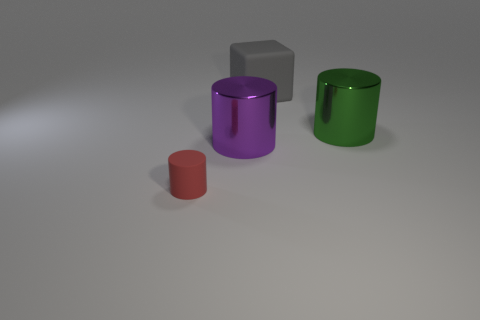There is a cube that is the same material as the red cylinder; what size is it?
Offer a terse response. Large. Is the number of tiny cyan shiny objects less than the number of large purple metallic things?
Your answer should be very brief. Yes. There is another cylinder that is the same size as the purple cylinder; what is its material?
Offer a terse response. Metal. Are there more large blue blocks than big things?
Make the answer very short. No. How many other objects are there of the same color as the rubber cube?
Ensure brevity in your answer.  0. What number of objects are both right of the gray matte object and to the left of the purple shiny cylinder?
Provide a succinct answer. 0. Are there any other things that have the same size as the rubber block?
Your answer should be very brief. Yes. Are there more big gray cubes in front of the large gray rubber cube than matte objects to the right of the big green cylinder?
Keep it short and to the point. No. There is a large thing that is to the left of the gray thing; what is it made of?
Provide a succinct answer. Metal. There is a tiny rubber object; is it the same shape as the rubber object that is right of the small rubber thing?
Keep it short and to the point. No. 